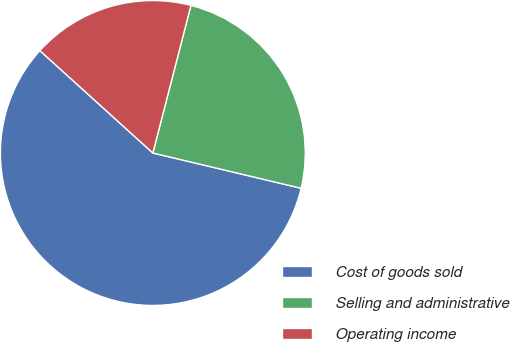Convert chart. <chart><loc_0><loc_0><loc_500><loc_500><pie_chart><fcel>Cost of goods sold<fcel>Selling and administrative<fcel>Operating income<nl><fcel>58.0%<fcel>24.7%<fcel>17.3%<nl></chart> 